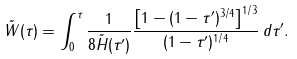<formula> <loc_0><loc_0><loc_500><loc_500>\tilde { W } ( \tau ) = \int _ { 0 } ^ { \tau } \frac { 1 } { 8 \tilde { H } ( \tau ^ { \prime } ) } \frac { \left [ 1 - ( 1 - \tau ^ { \prime } ) ^ { 3 / 4 } \right ] ^ { 1 / 3 } } { ( 1 - \tau ^ { \prime } ) ^ { 1 / 4 } } \, d \tau ^ { \prime } .</formula> 